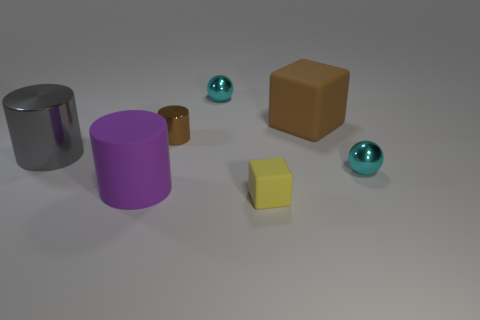What is the size of the rubber thing that is both behind the yellow cube and on the right side of the big purple rubber object?
Offer a terse response. Large. What is the material of the tiny cylinder that is the same color as the big block?
Give a very brief answer. Metal. Is the number of big brown rubber objects in front of the small matte object the same as the number of brown metallic objects?
Offer a very short reply. No. Do the gray shiny thing and the yellow matte object have the same size?
Make the answer very short. No. What color is the small thing that is both in front of the gray cylinder and behind the purple cylinder?
Offer a very short reply. Cyan. There is a purple object in front of the rubber block right of the tiny matte block; what is its material?
Your response must be concise. Rubber. The purple object that is the same shape as the tiny brown shiny thing is what size?
Provide a short and direct response. Large. There is a metallic ball that is in front of the brown matte block; is its color the same as the large metallic object?
Offer a terse response. No. Is the number of tiny cylinders less than the number of brown objects?
Offer a terse response. Yes. How many other objects are there of the same color as the small cylinder?
Your response must be concise. 1. 